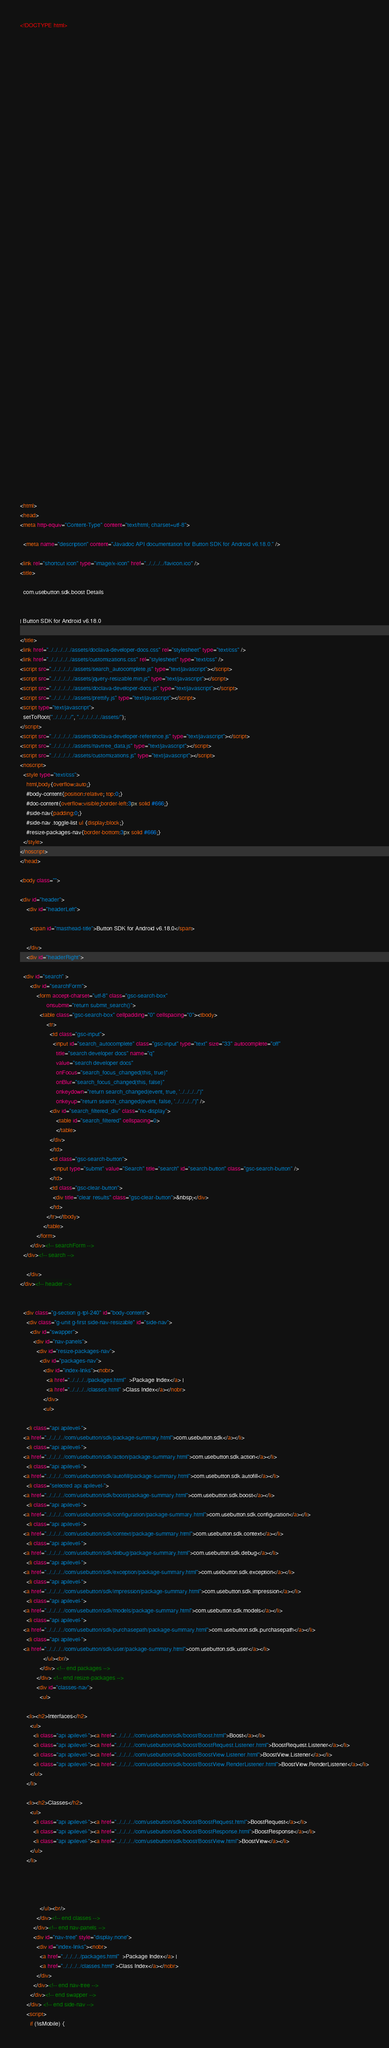<code> <loc_0><loc_0><loc_500><loc_500><_HTML_><!DOCTYPE html>

















































<html>
<head>
<meta http-equiv="Content-Type" content="text/html; charset=utf-8">

  <meta name="description" content="Javadoc API documentation for Button SDK for Android v6.18.0." />

<link rel="shortcut icon" type="image/x-icon" href="../../../../favicon.ico" />
<title>

  com.usebutton.sdk.boost Details


| Button SDK for Android v6.18.0

</title>
<link href="../../../../../assets/doclava-developer-docs.css" rel="stylesheet" type="text/css" />
<link href="../../../../../assets/customizations.css" rel="stylesheet" type="text/css" />
<script src="../../../../../assets/search_autocomplete.js" type="text/javascript"></script>
<script src="../../../../../assets/jquery-resizable.min.js" type="text/javascript"></script>
<script src="../../../../../assets/doclava-developer-docs.js" type="text/javascript"></script>
<script src="../../../../../assets/prettify.js" type="text/javascript"></script>
<script type="text/javascript">
  setToRoot("../../../../", "../../../../../assets/");
</script>
<script src="../../../../../assets/doclava-developer-reference.js" type="text/javascript"></script>
<script src="../../../../../assets/navtree_data.js" type="text/javascript"></script>
<script src="../../../../../assets/customizations.js" type="text/javascript"></script>
<noscript>
  <style type="text/css">
    html,body{overflow:auto;}
    #body-content{position:relative; top:0;}
    #doc-content{overflow:visible;border-left:3px solid #666;}
    #side-nav{padding:0;}
    #side-nav .toggle-list ul {display:block;}
    #resize-packages-nav{border-bottom:3px solid #666;}
  </style>
</noscript>
</head>

<body class="">

<div id="header">
    <div id="headerLeft">
    
      <span id="masthead-title">Button SDK for Android v6.18.0</span>
    
    </div>
    <div id="headerRight">
      
  <div id="search" >
      <div id="searchForm">
          <form accept-charset="utf-8" class="gsc-search-box" 
                onsubmit="return submit_search()">
            <table class="gsc-search-box" cellpadding="0" cellspacing="0"><tbody>
                <tr>
                  <td class="gsc-input">
                    <input id="search_autocomplete" class="gsc-input" type="text" size="33" autocomplete="off"
                      title="search developer docs" name="q"
                      value="search developer docs"
                      onFocus="search_focus_changed(this, true)"
                      onBlur="search_focus_changed(this, false)"
                      onkeydown="return search_changed(event, true, '../../../../')"
                      onkeyup="return search_changed(event, false, '../../../../')" />
                  <div id="search_filtered_div" class="no-display">
                      <table id="search_filtered" cellspacing=0>
                      </table>
                  </div>
                  </td>
                  <td class="gsc-search-button">
                    <input type="submit" value="Search" title="search" id="search-button" class="gsc-search-button" />
                  </td>
                  <td class="gsc-clear-button">
                    <div title="clear results" class="gsc-clear-button">&nbsp;</div>
                  </td>
                </tr></tbody>
              </table>
          </form>
      </div><!-- searchForm -->
  </div><!-- search -->
      
    </div>
</div><!-- header -->


  <div class="g-section g-tpl-240" id="body-content">
    <div class="g-unit g-first side-nav-resizable" id="side-nav">
      <div id="swapper">
        <div id="nav-panels">
          <div id="resize-packages-nav">
            <div id="packages-nav">
              <div id="index-links"><nobr>
                <a href="../../../../packages.html"  >Package Index</a> | 
                <a href="../../../../classes.html" >Class Index</a></nobr>
              </div>
              <ul>
                
    <li class="api apilevel-">
  <a href="../../../../com/usebutton/sdk/package-summary.html">com.usebutton.sdk</a></li>
    <li class="api apilevel-">
  <a href="../../../../com/usebutton/sdk/action/package-summary.html">com.usebutton.sdk.action</a></li>
    <li class="api apilevel-">
  <a href="../../../../com/usebutton/sdk/autofill/package-summary.html">com.usebutton.sdk.autofill</a></li>
    <li class="selected api apilevel-">
  <a href="../../../../com/usebutton/sdk/boost/package-summary.html">com.usebutton.sdk.boost</a></li>
    <li class="api apilevel-">
  <a href="../../../../com/usebutton/sdk/configuration/package-summary.html">com.usebutton.sdk.configuration</a></li>
    <li class="api apilevel-">
  <a href="../../../../com/usebutton/sdk/context/package-summary.html">com.usebutton.sdk.context</a></li>
    <li class="api apilevel-">
  <a href="../../../../com/usebutton/sdk/debug/package-summary.html">com.usebutton.sdk.debug</a></li>
    <li class="api apilevel-">
  <a href="../../../../com/usebutton/sdk/exception/package-summary.html">com.usebutton.sdk.exception</a></li>
    <li class="api apilevel-">
  <a href="../../../../com/usebutton/sdk/impression/package-summary.html">com.usebutton.sdk.impression</a></li>
    <li class="api apilevel-">
  <a href="../../../../com/usebutton/sdk/models/package-summary.html">com.usebutton.sdk.models</a></li>
    <li class="api apilevel-">
  <a href="../../../../com/usebutton/sdk/purchasepath/package-summary.html">com.usebutton.sdk.purchasepath</a></li>
    <li class="api apilevel-">
  <a href="../../../../com/usebutton/sdk/user/package-summary.html">com.usebutton.sdk.user</a></li>
              </ul><br/>
            </div> <!-- end packages -->
          </div> <!-- end resize-packages -->
          <div id="classes-nav">
            <ul>
              
    <li><h2>Interfaces</h2>
      <ul>
        <li class="api apilevel-"><a href="../../../../com/usebutton/sdk/boost/Boost.html">Boost</a></li>
        <li class="api apilevel-"><a href="../../../../com/usebutton/sdk/boost/BoostRequest.Listener.html">BoostRequest.Listener</a></li>
        <li class="api apilevel-"><a href="../../../../com/usebutton/sdk/boost/BoostView.Listener.html">BoostView.Listener</a></li>
        <li class="api apilevel-"><a href="../../../../com/usebutton/sdk/boost/BoostView.RenderListener.html">BoostView.RenderListener</a></li>
      </ul>
    </li>
              
    <li><h2>Classes</h2>
      <ul>
        <li class="api apilevel-"><a href="../../../../com/usebutton/sdk/boost/BoostRequest.html">BoostRequest</a></li>
        <li class="api apilevel-"><a href="../../../../com/usebutton/sdk/boost/BoostResponse.html">BoostResponse</a></li>
        <li class="api apilevel-"><a href="../../../../com/usebutton/sdk/boost/BoostView.html">BoostView</a></li>
      </ul>
    </li>
              
              
              
              
            </ul><br/>
          </div><!-- end classes -->
        </div><!-- end nav-panels -->
        <div id="nav-tree" style="display:none">
          <div id="index-links"><nobr>
            <a href="../../../../packages.html"  >Package Index</a> | 
            <a href="../../../../classes.html" >Class Index</a></nobr>
          </div>
        </div><!-- end nav-tree -->
      </div><!-- end swapper -->
    </div> <!-- end side-nav -->
    <script>
      if (!isMobile) {</code> 